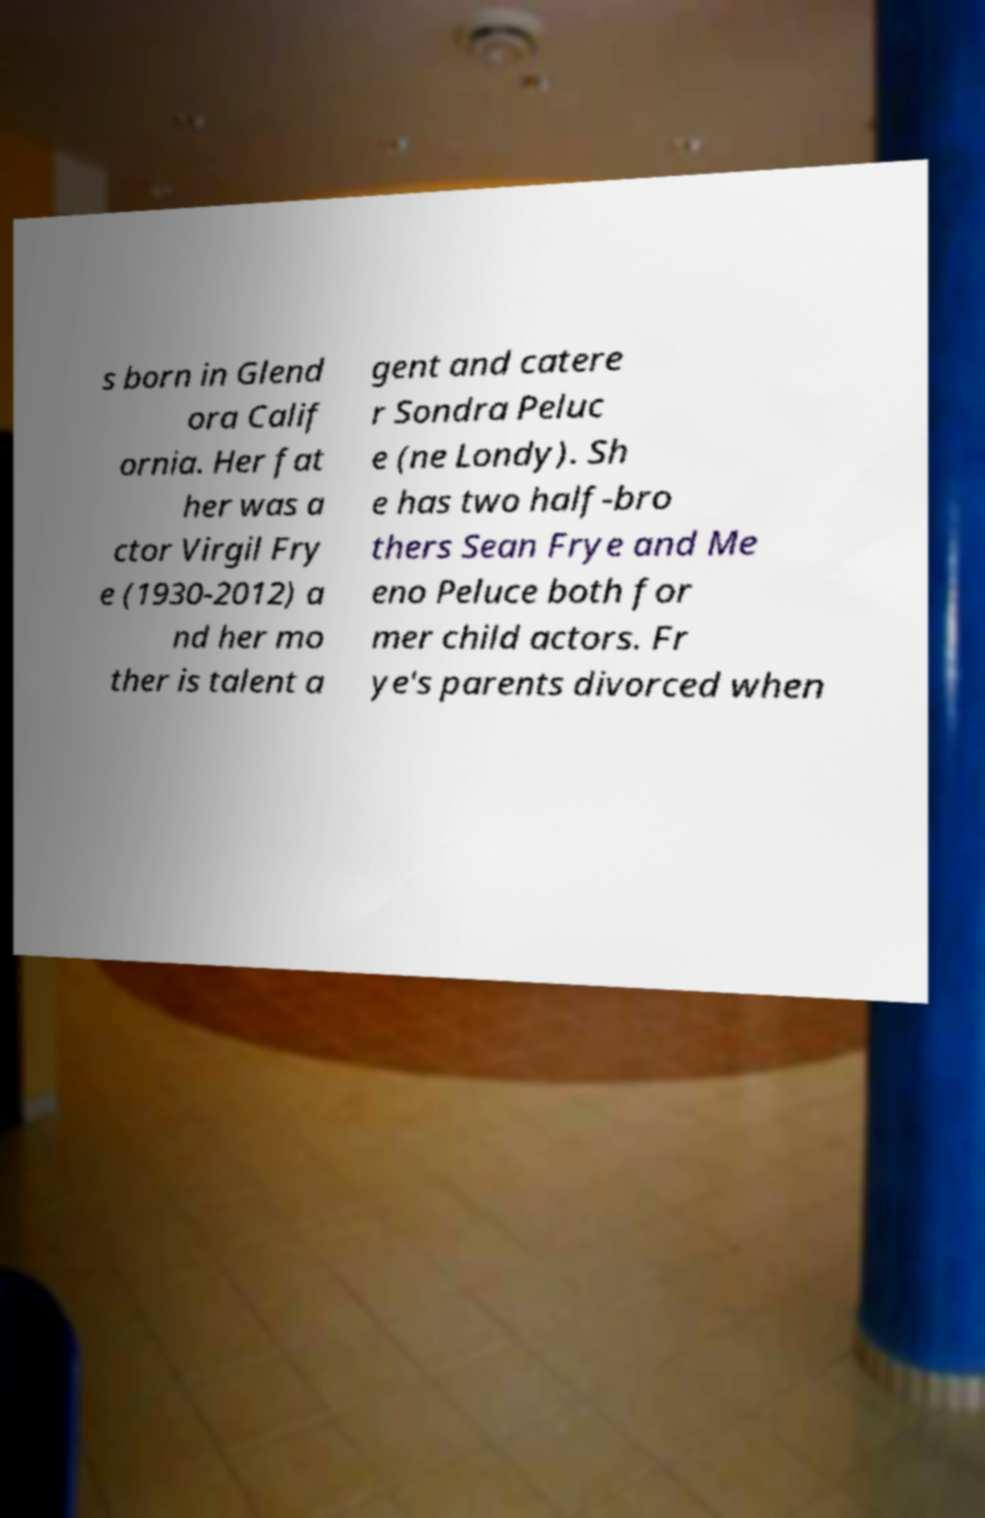Please identify and transcribe the text found in this image. s born in Glend ora Calif ornia. Her fat her was a ctor Virgil Fry e (1930-2012) a nd her mo ther is talent a gent and catere r Sondra Peluc e (ne Londy). Sh e has two half-bro thers Sean Frye and Me eno Peluce both for mer child actors. Fr ye's parents divorced when 